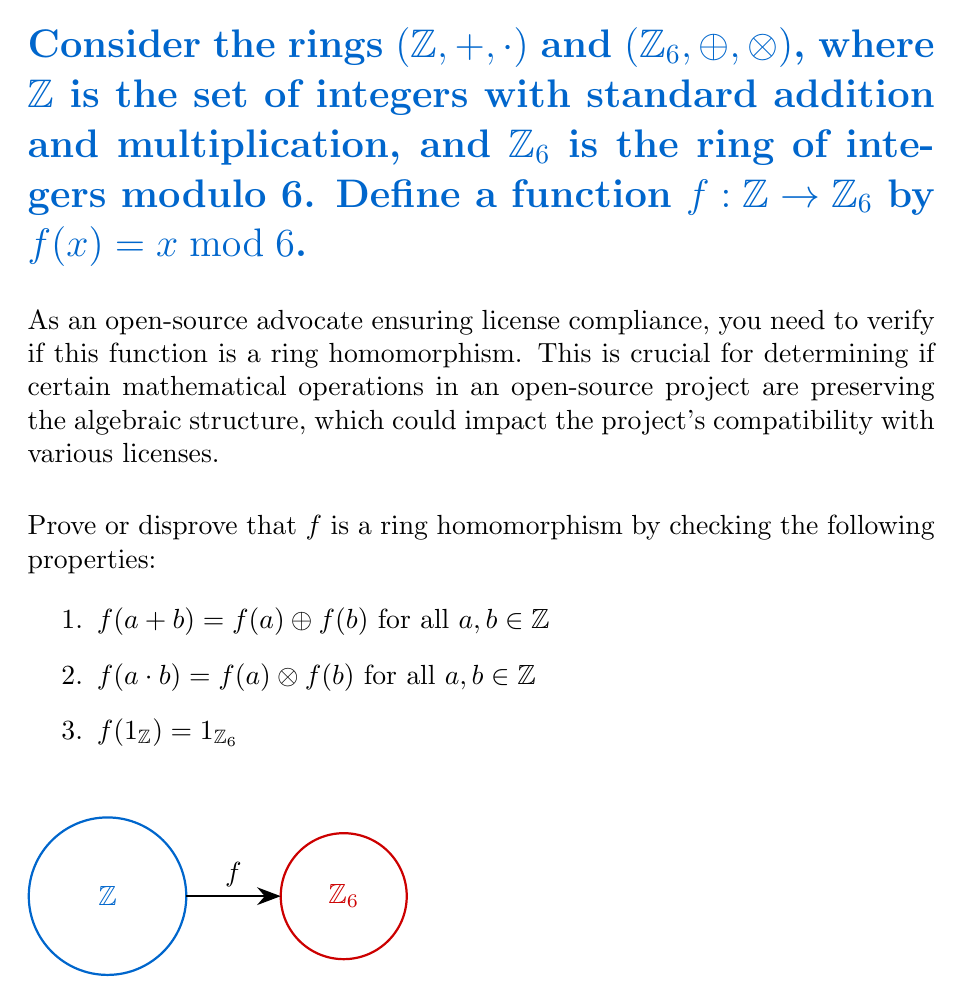Provide a solution to this math problem. Let's verify each property of a ring homomorphism for the function $f(x) = x \bmod 6$:

1) $f(a + b) = f(a) \oplus f(b)$ for all $a, b \in \mathbb{Z}$

Let $a, b \in \mathbb{Z}$. Then:
$f(a + b) = (a + b) \bmod 6$
$f(a) \oplus f(b) = (a \bmod 6) \oplus (b \bmod 6)$

These are equal because $(a + b) \bmod 6 = ((a \bmod 6) + (b \bmod 6)) \bmod 6$, which is the definition of addition in $\mathbb{Z}_6$.

2) $f(a \cdot b) = f(a) \otimes f(b)$ for all $a, b \in \mathbb{Z}$

Let $a, b \in \mathbb{Z}$. Then:
$f(a \cdot b) = (a \cdot b) \bmod 6$
$f(a) \otimes f(b) = (a \bmod 6) \otimes (b \bmod 6)$

These are equal because $(a \cdot b) \bmod 6 = ((a \bmod 6) \cdot (b \bmod 6)) \bmod 6$, which is the definition of multiplication in $\mathbb{Z}_6$.

3) $f(1_{\mathbb{Z}}) = 1_{\mathbb{Z}_6}$

$f(1_{\mathbb{Z}}) = 1 \bmod 6 = 1 = 1_{\mathbb{Z}_6}$

Since all three properties are satisfied, $f$ is indeed a ring homomorphism.
Answer: Yes, $f$ is a ring homomorphism. 